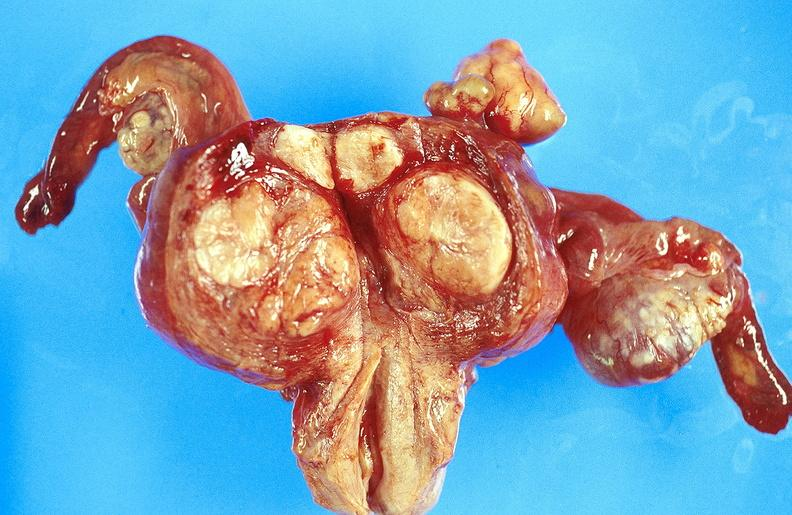where does this part belong to?
Answer the question using a single word or phrase. Female reproductive system 